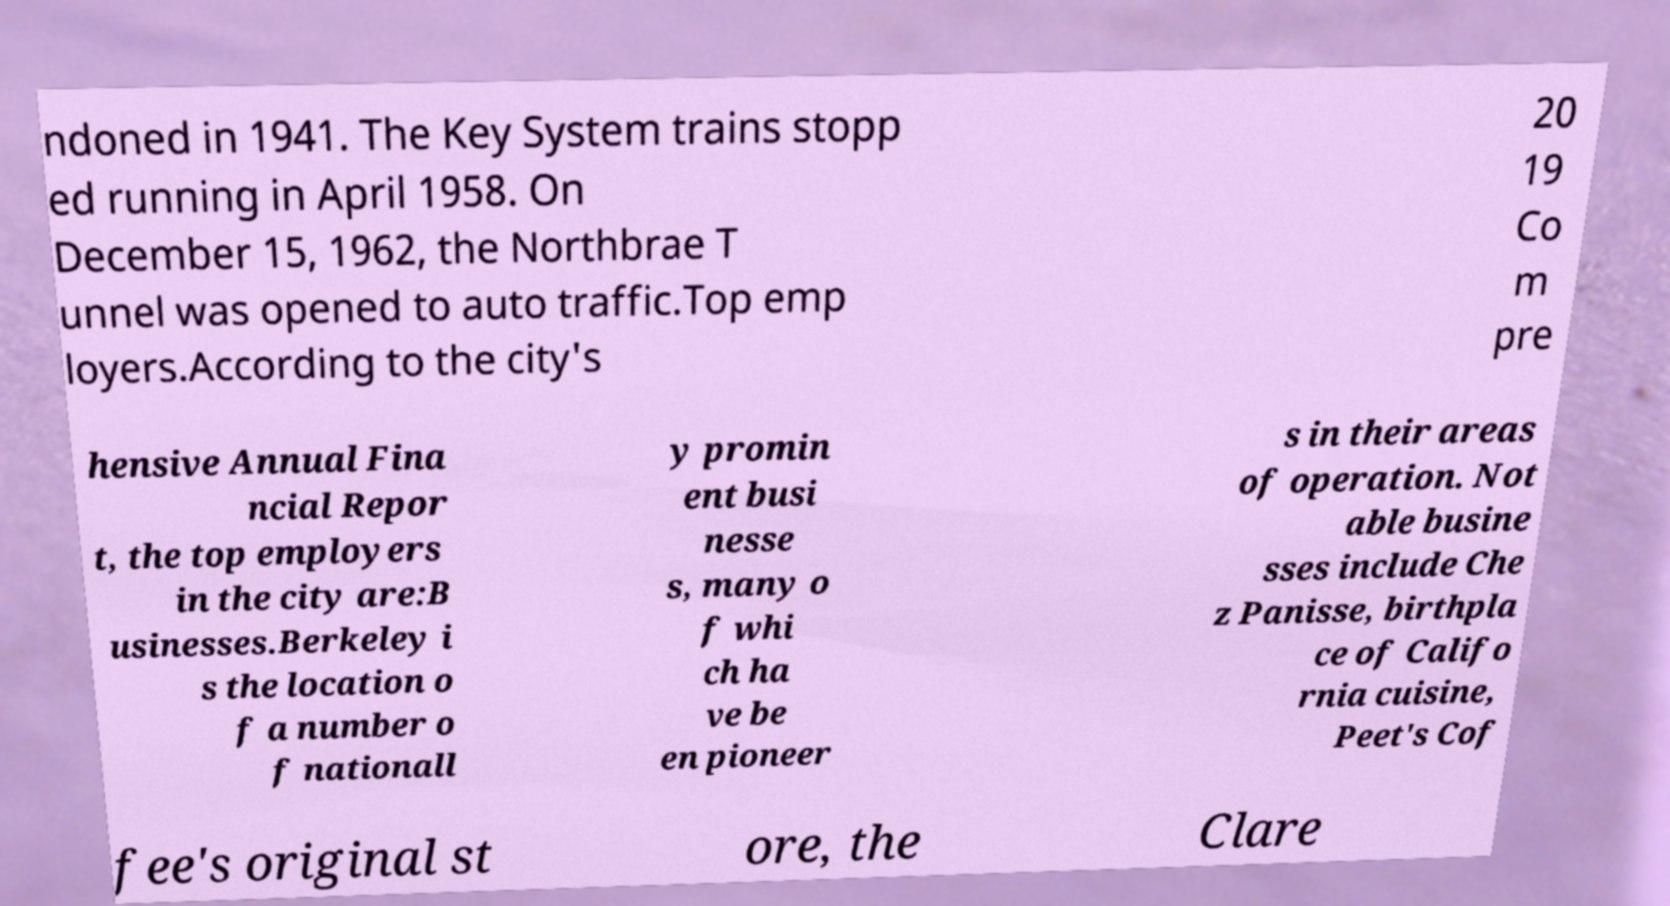Can you accurately transcribe the text from the provided image for me? ndoned in 1941. The Key System trains stopp ed running in April 1958. On December 15, 1962, the Northbrae T unnel was opened to auto traffic.Top emp loyers.According to the city's 20 19 Co m pre hensive Annual Fina ncial Repor t, the top employers in the city are:B usinesses.Berkeley i s the location o f a number o f nationall y promin ent busi nesse s, many o f whi ch ha ve be en pioneer s in their areas of operation. Not able busine sses include Che z Panisse, birthpla ce of Califo rnia cuisine, Peet's Cof fee's original st ore, the Clare 